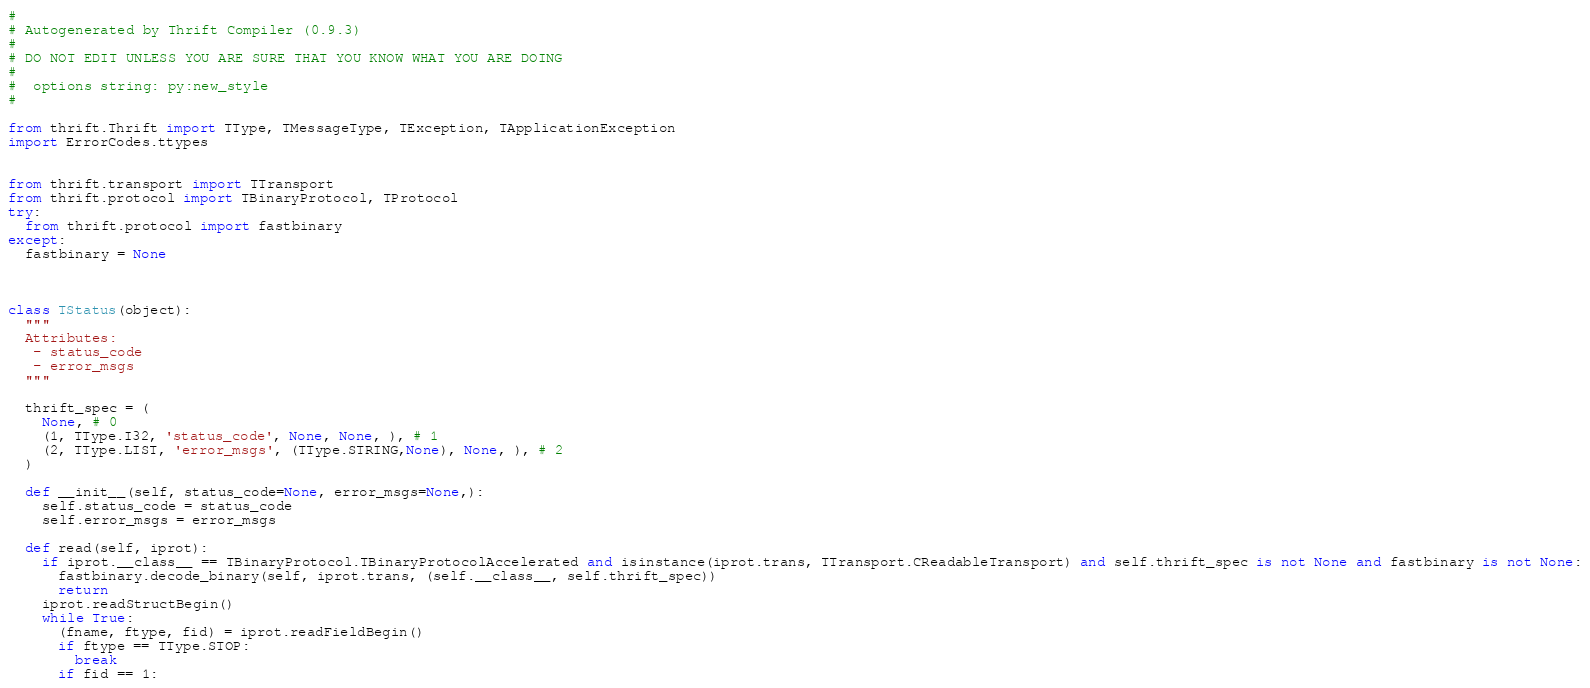Convert code to text. <code><loc_0><loc_0><loc_500><loc_500><_Python_>#
# Autogenerated by Thrift Compiler (0.9.3)
#
# DO NOT EDIT UNLESS YOU ARE SURE THAT YOU KNOW WHAT YOU ARE DOING
#
#  options string: py:new_style
#

from thrift.Thrift import TType, TMessageType, TException, TApplicationException
import ErrorCodes.ttypes


from thrift.transport import TTransport
from thrift.protocol import TBinaryProtocol, TProtocol
try:
  from thrift.protocol import fastbinary
except:
  fastbinary = None



class TStatus(object):
  """
  Attributes:
   - status_code
   - error_msgs
  """

  thrift_spec = (
    None, # 0
    (1, TType.I32, 'status_code', None, None, ), # 1
    (2, TType.LIST, 'error_msgs', (TType.STRING,None), None, ), # 2
  )

  def __init__(self, status_code=None, error_msgs=None,):
    self.status_code = status_code
    self.error_msgs = error_msgs

  def read(self, iprot):
    if iprot.__class__ == TBinaryProtocol.TBinaryProtocolAccelerated and isinstance(iprot.trans, TTransport.CReadableTransport) and self.thrift_spec is not None and fastbinary is not None:
      fastbinary.decode_binary(self, iprot.trans, (self.__class__, self.thrift_spec))
      return
    iprot.readStructBegin()
    while True:
      (fname, ftype, fid) = iprot.readFieldBegin()
      if ftype == TType.STOP:
        break
      if fid == 1:</code> 